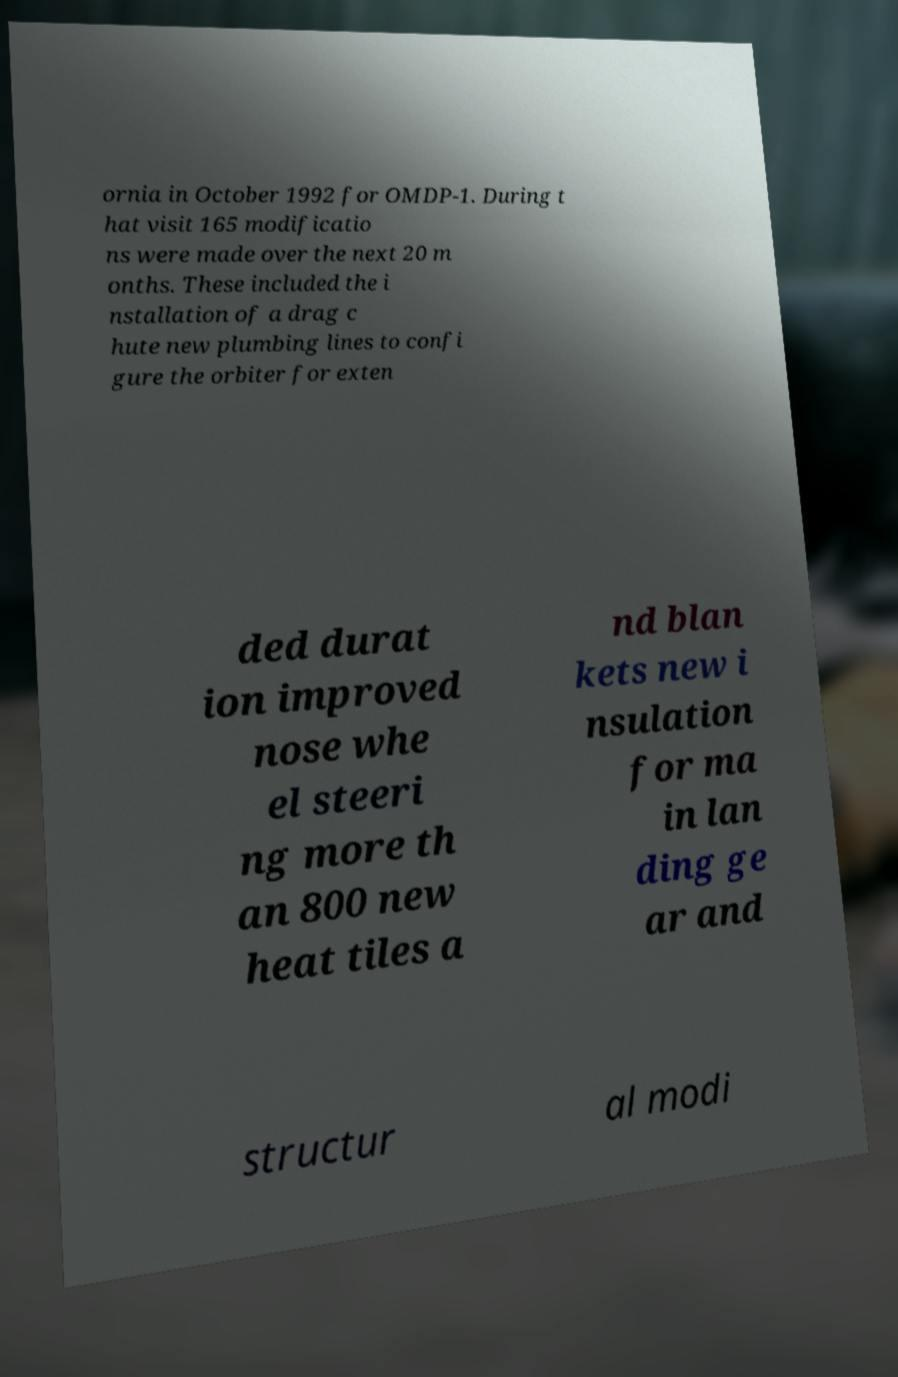Please read and relay the text visible in this image. What does it say? ornia in October 1992 for OMDP-1. During t hat visit 165 modificatio ns were made over the next 20 m onths. These included the i nstallation of a drag c hute new plumbing lines to confi gure the orbiter for exten ded durat ion improved nose whe el steeri ng more th an 800 new heat tiles a nd blan kets new i nsulation for ma in lan ding ge ar and structur al modi 